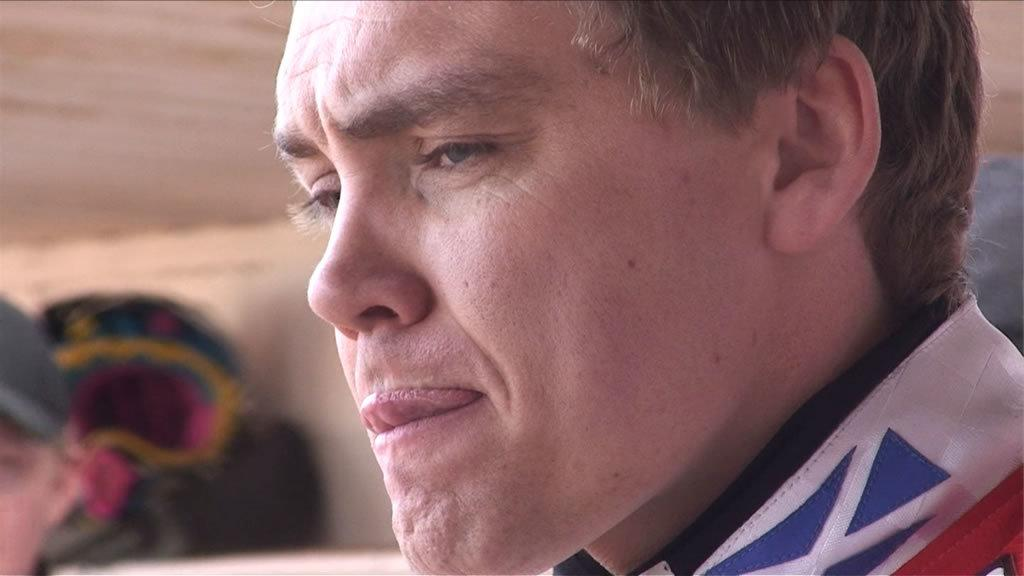What is the main subject of the image? There is a person in the image. In which direction is the person facing? The person is facing towards the left side. Can you describe anything about the other people in the image? There is another person's head visible on the left side of the image. How would you describe the background of the image? The background of the image is blurred. What type of fruit is being held by the person in the image? There is no fruit visible in the image. Can you describe the flowers in the background of the image? There are no flowers present in the image; the background is blurred. 